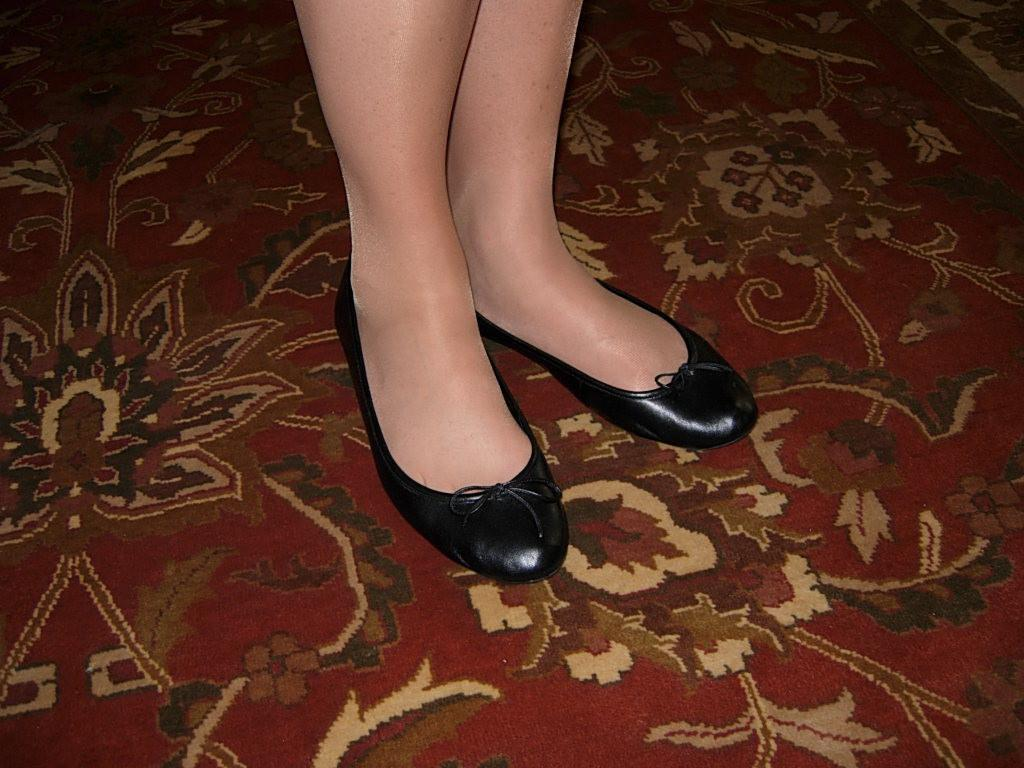What part of a woman's body is visible in the image? The image shows the legs of a woman. What type of footwear is the woman wearing? The woman is wearing black color shoes. What can be seen on the floor in the image? There is a carpet on the floor in the image. Is there any steam coming out of the shoes in the image? No, there is no steam present in the image. 